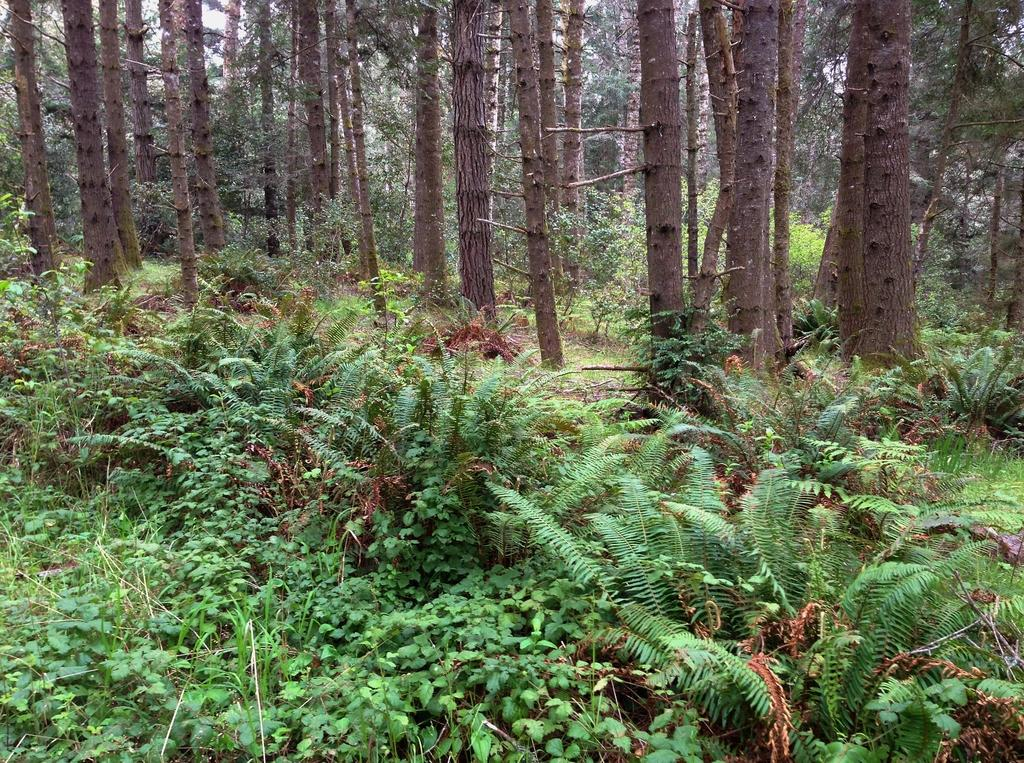What type of vegetation is present at the bottom of the image? There are plants and grass at the bottom of the image. What can be seen in the center of the image? There are trees in the center of the image. What type of ornament is hanging from the trees in the image? There is no ornament present in the image; it only features plants, grass, and trees. How does the net affect the growth of the plants in the image? There is no net present in the image, so it cannot affect the growth of the plants. 